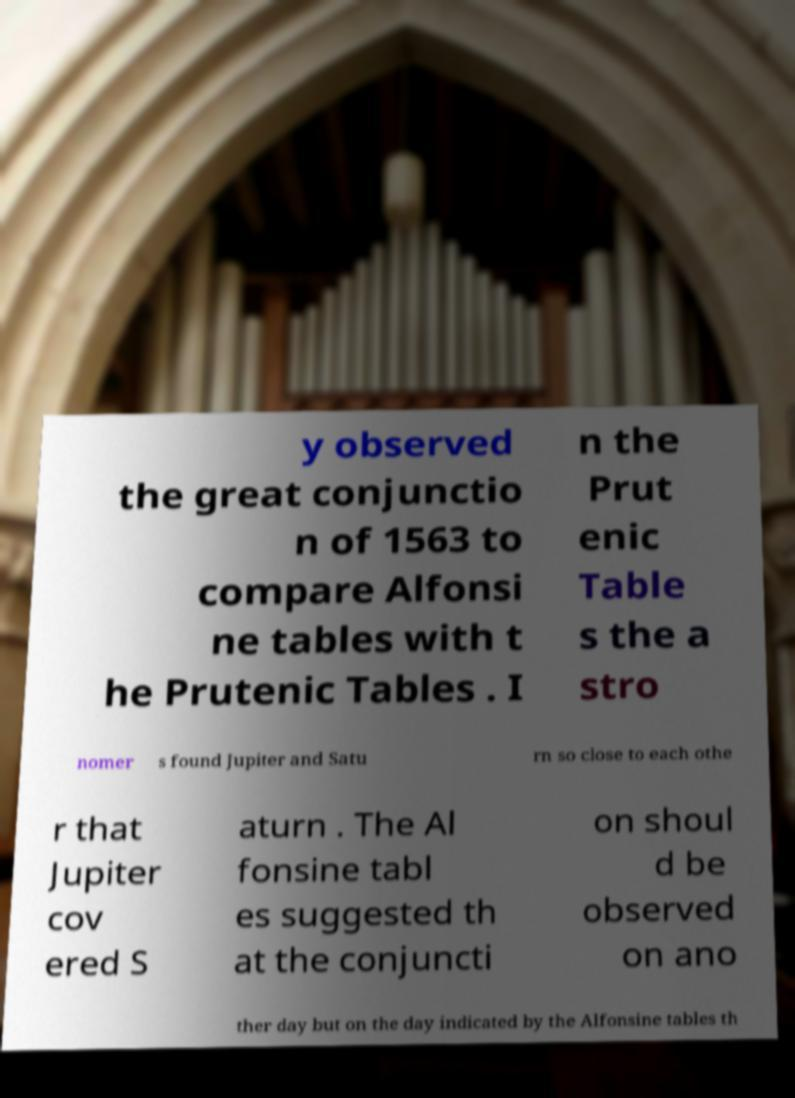Please read and relay the text visible in this image. What does it say? y observed the great conjunctio n of 1563 to compare Alfonsi ne tables with t he Prutenic Tables . I n the Prut enic Table s the a stro nomer s found Jupiter and Satu rn so close to each othe r that Jupiter cov ered S aturn . The Al fonsine tabl es suggested th at the conjuncti on shoul d be observed on ano ther day but on the day indicated by the Alfonsine tables th 